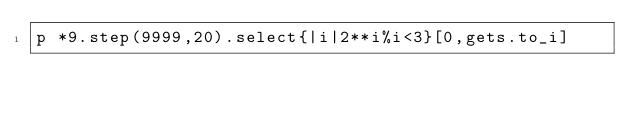<code> <loc_0><loc_0><loc_500><loc_500><_Ruby_>p *9.step(9999,20).select{|i|2**i%i<3}[0,gets.to_i]</code> 